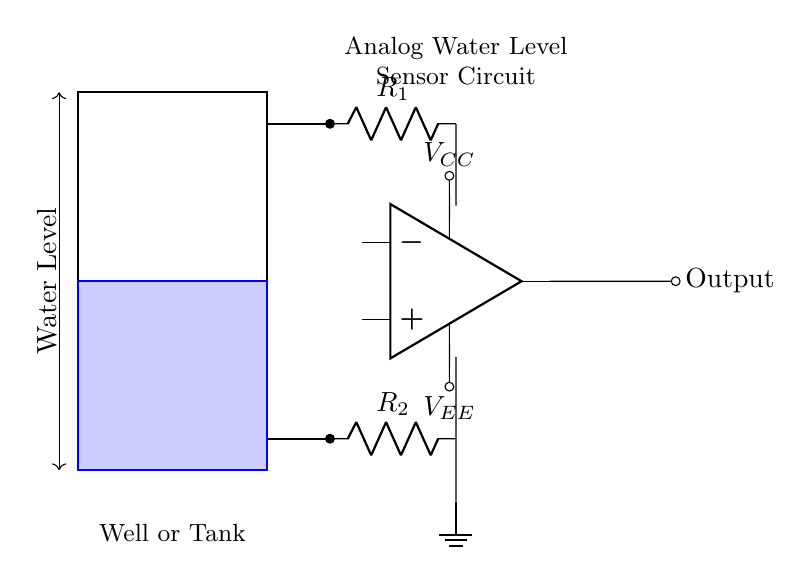What does the rectangle represent? The rectangle represents the water tank or well, showing its physical boundaries in the circuit diagram.
Answer: Water tank What do the blue lines indicate? The blue lines indicate the filled portion of the water tank, representing the current water level.
Answer: Water level What is the purpose of the op-amp in this circuit? The op-amp amplifies the voltage signal derived from the resistance of the water, enabling accurate level monitoring.
Answer: Amplification How many resistors are in the circuit? There are two resistors in the circuit, labeled R1 and R2, which are used to create the voltage divider.
Answer: Two How does the water level affect the output voltage? The output voltage of the op-amp varies based on the water level; as the water level rises or falls, the resistance changes, affecting the output voltage proportionally.
Answer: It varies What are the voltage supply connections labeled as? The voltage supply connections are labeled as VCC for the positive supply and VEE for the negative supply to the op-amp, ensuring it operates correctly.
Answer: VCC and VEE 